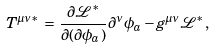<formula> <loc_0><loc_0><loc_500><loc_500>T ^ { \mu \nu * } \, = \, \frac { \partial \mathcal { L ^ { * } } } { \partial ( \partial \phi _ { a } ) } \partial ^ { \nu } \phi _ { a } - g ^ { \mu \nu } \mathcal { L ^ { * } } ,</formula> 